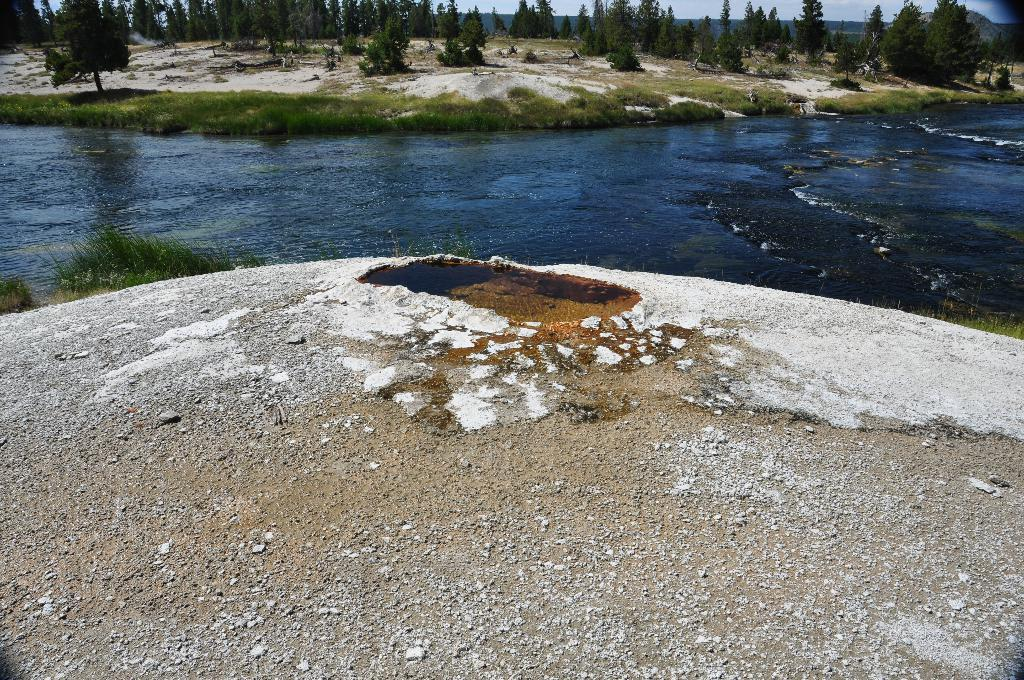What type of terrain is visible in the image? Ground and water are visible in the image. What type of vegetation can be seen in the image? Grass, plants, and trees are visible in the image. What part of the natural environment is visible in the image? The sky is visible in the image. What color is the robin's stomach in the image? There is no robin present in the image, so its stomach color cannot be determined. 